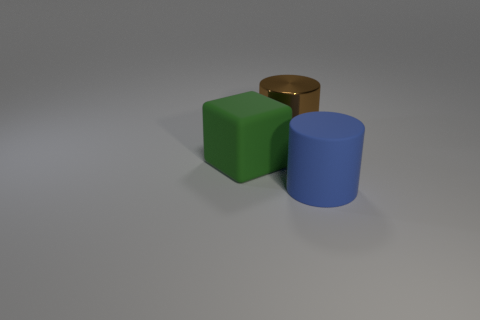Is there a rubber thing that is on the right side of the matte thing to the right of the brown metal cylinder?
Offer a very short reply. No. What is the color of the other thing that is the same shape as the shiny thing?
Your response must be concise. Blue. How many matte things have the same color as the matte cube?
Your response must be concise. 0. What color is the cylinder in front of the big object that is behind the thing that is on the left side of the big metallic object?
Keep it short and to the point. Blue. Is the material of the large green cube the same as the large brown object?
Your answer should be very brief. No. Is the metal thing the same shape as the big green object?
Give a very brief answer. No. Are there the same number of blue cylinders that are on the right side of the large cube and big green blocks behind the brown metal cylinder?
Your response must be concise. No. There is a cylinder that is the same material as the green object; what is its color?
Your response must be concise. Blue. How many big brown objects are made of the same material as the large blue cylinder?
Your response must be concise. 0. Is the color of the cylinder in front of the large brown metal cylinder the same as the matte cube?
Offer a terse response. No. 